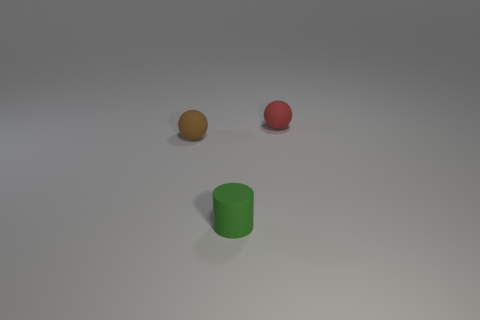Does the tiny ball behind the small brown rubber thing have the same material as the ball left of the green matte thing?
Give a very brief answer. Yes. How many things are either matte objects behind the tiny matte cylinder or small green rubber objects?
Your answer should be compact. 3. Is the number of brown objects to the left of the red matte sphere less than the number of spheres behind the brown object?
Your answer should be compact. No. What number of other objects are the same size as the red matte thing?
Give a very brief answer. 2. Do the red sphere and the small thing that is in front of the small brown matte ball have the same material?
Your answer should be compact. Yes. What number of things are either tiny rubber objects that are in front of the red rubber thing or things behind the tiny green cylinder?
Give a very brief answer. 3. What color is the tiny rubber cylinder?
Provide a short and direct response. Green. Are there fewer tiny green cylinders that are behind the tiny red thing than small cyan blocks?
Your response must be concise. No. Is there anything else that has the same shape as the brown thing?
Your answer should be very brief. Yes. Are there any big red shiny spheres?
Provide a short and direct response. No. 